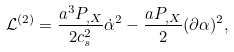Convert formula to latex. <formula><loc_0><loc_0><loc_500><loc_500>\mathcal { L } ^ { ( 2 ) } = \frac { a ^ { 3 } P _ { , X } } { 2 c _ { s } ^ { 2 } } \dot { \alpha } ^ { 2 } - \frac { a P _ { , X } } { 2 } ( \partial \alpha ) ^ { 2 } ,</formula> 